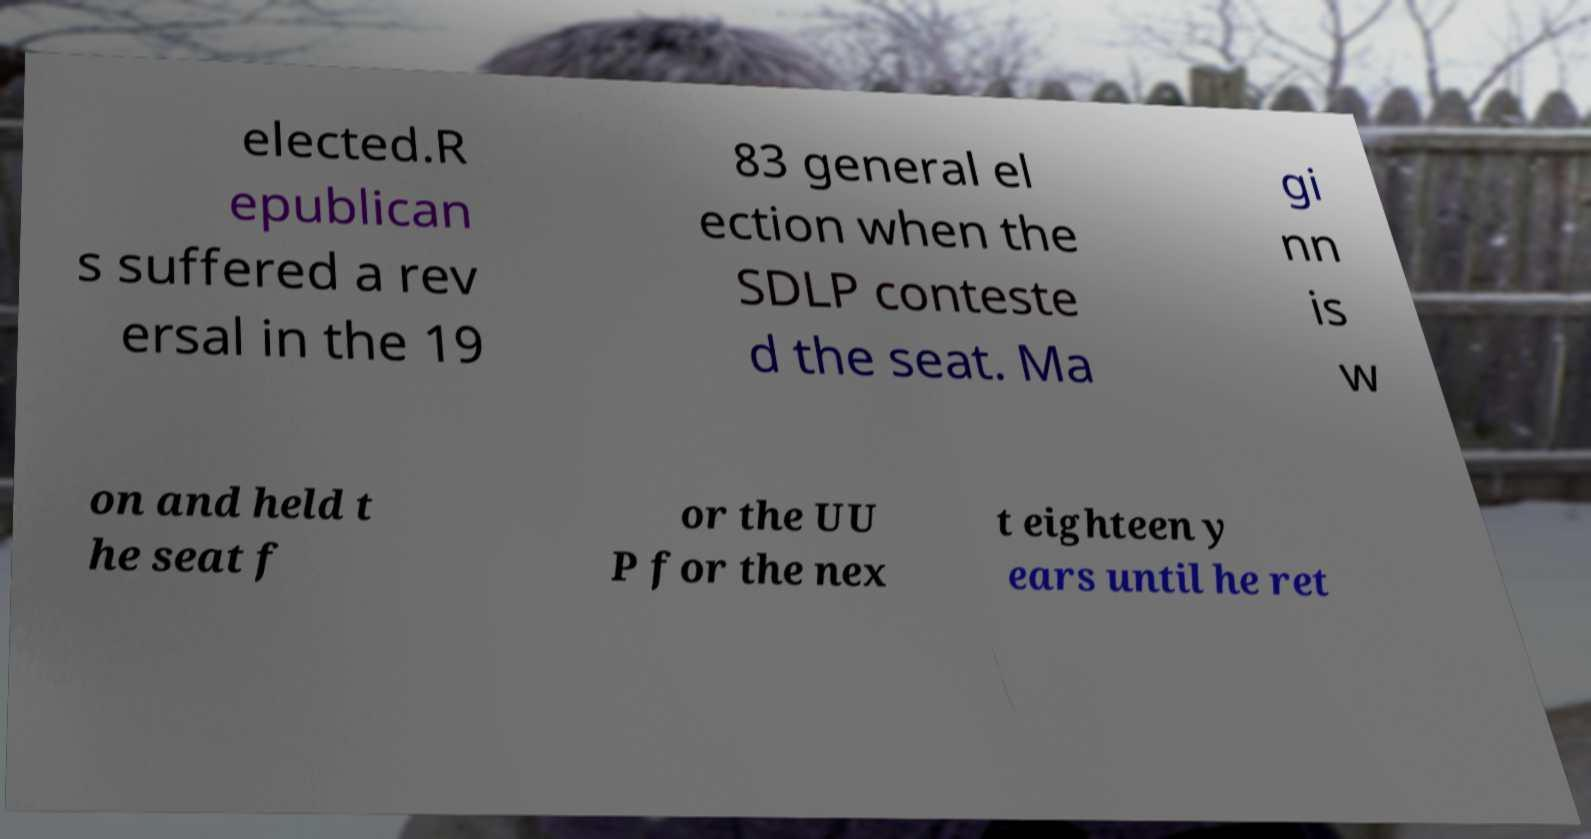Could you extract and type out the text from this image? elected.R epublican s suffered a rev ersal in the 19 83 general el ection when the SDLP conteste d the seat. Ma gi nn is w on and held t he seat f or the UU P for the nex t eighteen y ears until he ret 